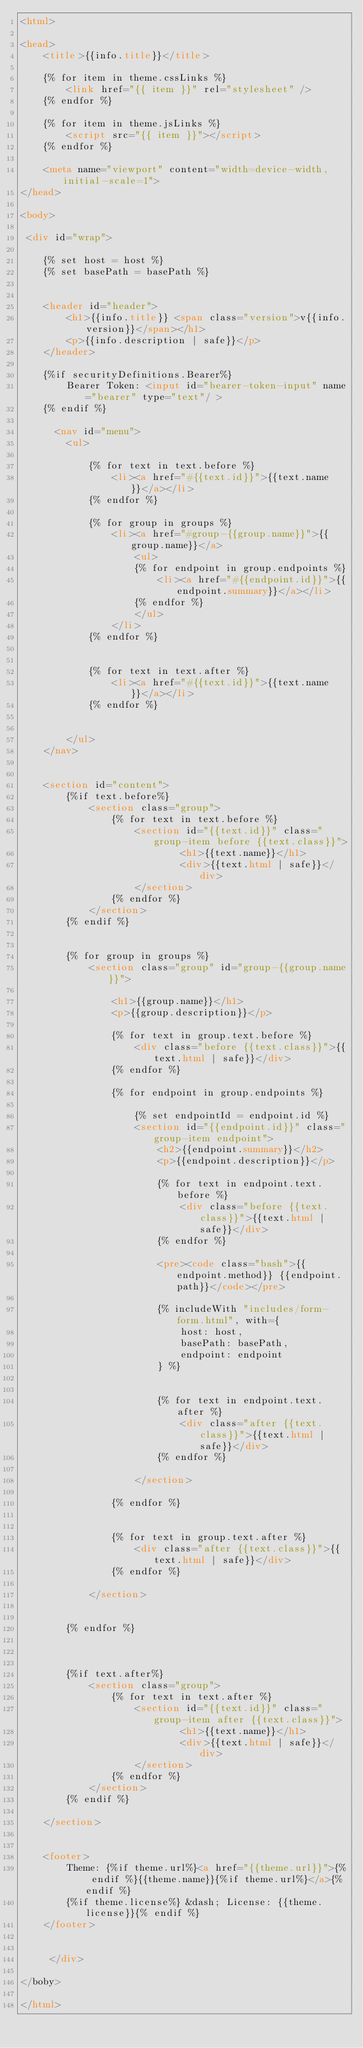<code> <loc_0><loc_0><loc_500><loc_500><_HTML_><html>

<head>
    <title>{{info.title}}</title>

    {% for item in theme.cssLinks %}
        <link href="{{ item }}" rel="stylesheet" />
    {% endfor %}

    {% for item in theme.jsLinks %}
        <script src="{{ item }}"></script>
    {% endfor %}

    <meta name="viewport" content="width=device-width, initial-scale=1">
</head>

<body>

 <div id="wrap">

    {% set host = host %}
    {% set basePath = basePath %}


    <header id="header">
        <h1>{{info.title}} <span class="version">v{{info.version}}</span></h1>
        <p>{{info.description | safe}}</p>
    </header>

    {%if securityDefinitions.Bearer%}
        Bearer Token: <input id="bearer-token-input" name="bearer" type="text"/ >
    {% endif %}

      <nav id="menu">
        <ul>

            {% for text in text.before %}
                <li><a href="#{{text.id}}">{{text.name}}</a></li>
            {% endfor %}

            {% for group in groups %}
                <li><a href="#group-{{group.name}}">{{group.name}}</a>
                    <ul>
                    {% for endpoint in group.endpoints %}
                        <li><a href="#{{endpoint.id}}">{{endpoint.summary}}</a></li>
                    {% endfor %}
                    </ul>
                </li>
            {% endfor %}


            {% for text in text.after %}
                <li><a href="#{{text.id}}">{{text.name}}</a></li>
            {% endfor %}


        </ul>
    </nav>


    <section id="content">
        {%if text.before%}
            <section class="group">
                {% for text in text.before %}
                    <section id="{{text.id}}" class="group-item before {{text.class}}">
                            <h1>{{text.name}}</h1>
                            <div>{{text.html | safe}}</div>
                    </section>
                {% endfor %}
            </section>
        {% endif %}


        {% for group in groups %}
            <section class="group" id="group-{{group.name}}">

                <h1>{{group.name}}</h1>
                <p>{{group.description}}</p>

                {% for text in group.text.before %}
                    <div class="before {{text.class}}">{{text.html | safe}}</div>
                {% endfor %}

                {% for endpoint in group.endpoints %}

                    {% set endpointId = endpoint.id %}
                    <section id="{{endpoint.id}}" class="group-item endpoint">
                        <h2>{{endpoint.summary}}</h2>
                        <p>{{endpoint.description}}</p>

                        {% for text in endpoint.text.before %}
                            <div class="before {{text.class}}">{{text.html | safe}}</div>
                        {% endfor %}

                        <pre><code class="bash">{{endpoint.method}} {{endpoint.path}}</code></pre>

                        {% includeWith "includes/form-form.html", with={
                            host: host,
                            basePath: basePath,
                            endpoint: endpoint
                        } %}


                        {% for text in endpoint.text.after %}
                            <div class="after {{text.class}}">{{text.html | safe}}</div>
                        {% endfor %}

                    </section>

                {% endfor %}


                {% for text in group.text.after %}
                    <div class="after {{text.class}}">{{text.html | safe}}</div>
                {% endfor %}

            </section>


        {% endfor %}



        {%if text.after%}
            <section class="group">
                {% for text in text.after %}
                    <section id="{{text.id}}" class="group-item after {{text.class}}">
                            <h1>{{text.name}}</h1>
                            <div>{{text.html | safe}}</div>
                    </section>
                {% endfor %}
            </section>
        {% endif %}

    </section>


    <footer>
        Theme: {%if theme.url%}<a href="{{theme.url}}">{% endif %}{{theme.name}}{%if theme.url%}</a>{% endif %}
        {%if theme.license%} &dash; License: {{theme.license}}{% endif %}
    </footer>


     </div>

</boby>

</html>
</code> 